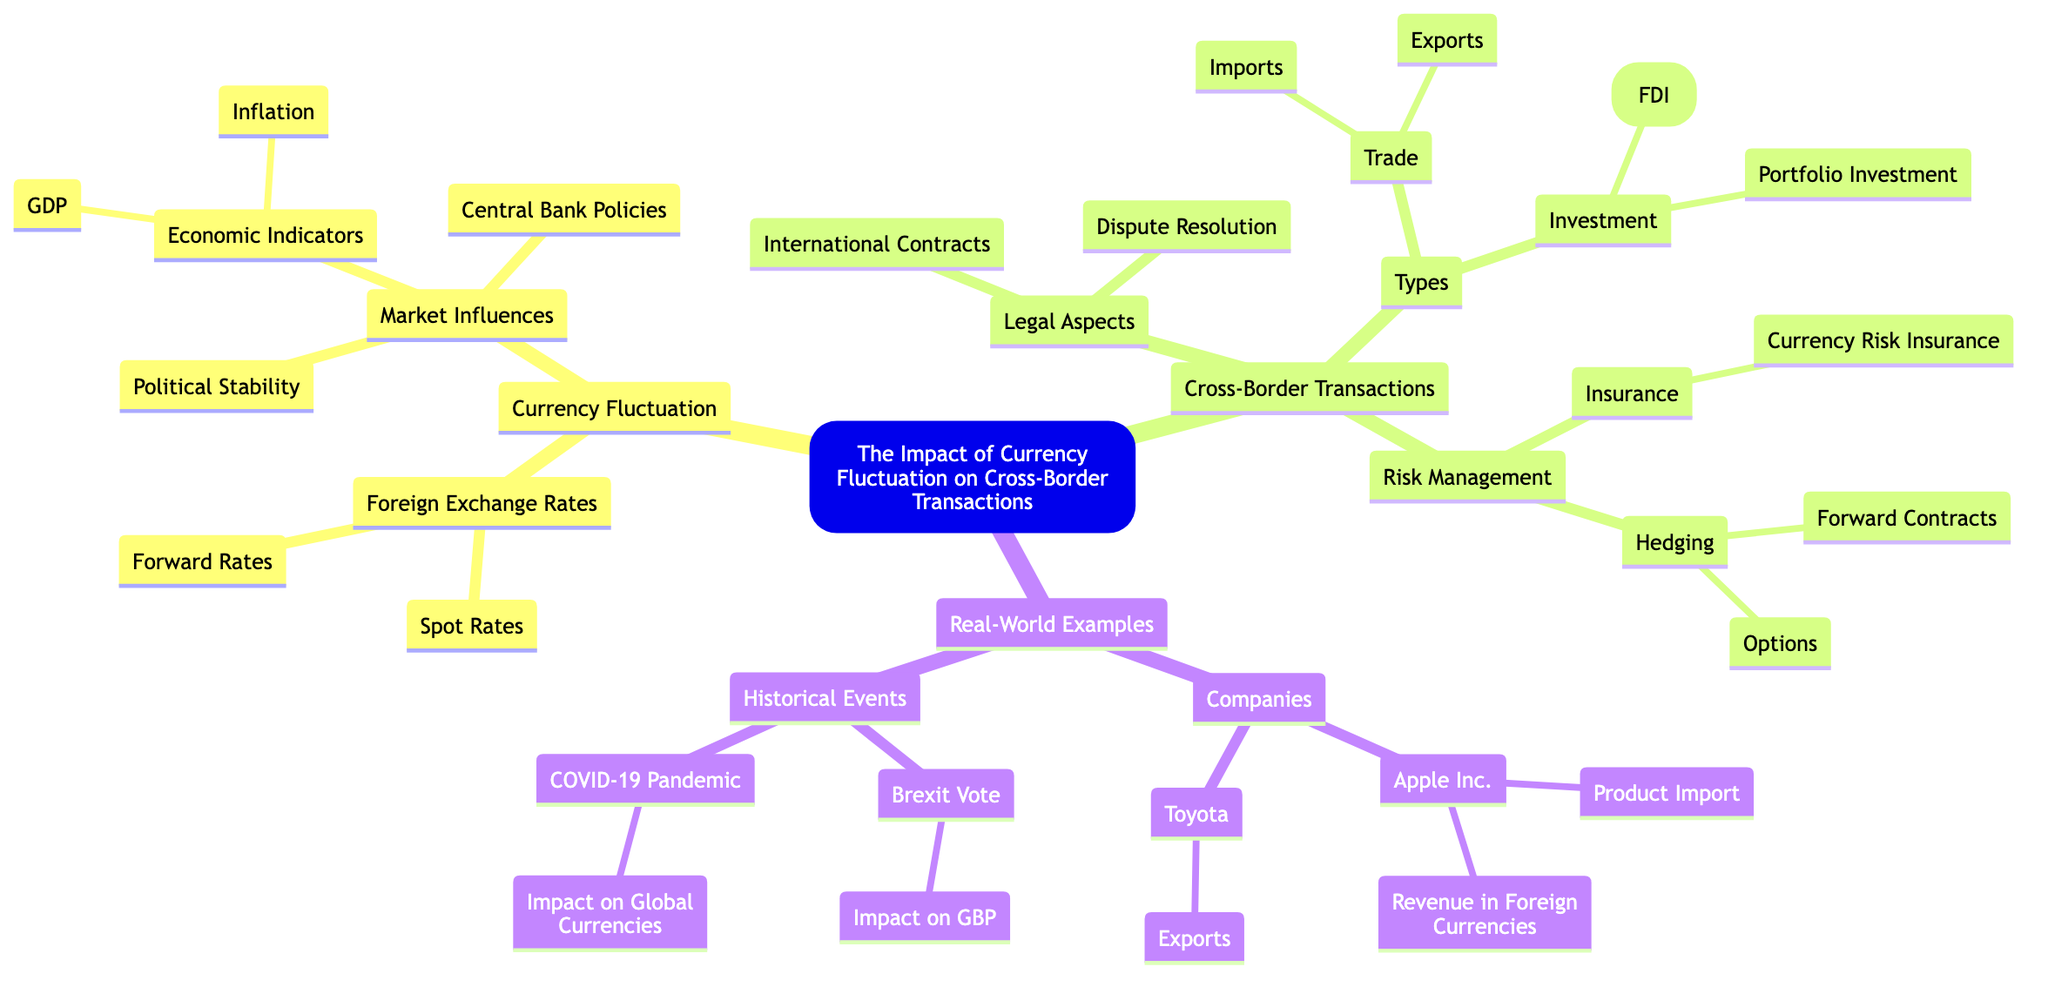What are the two main components of Currency Fluctuation? The diagram shows that Currency Fluctuation consists of two main components: Foreign Exchange Rates and Market Influences.
Answer: Foreign Exchange Rates, Market Influences How many types of Cross-Border Transactions are listed in the diagram? The diagram indicates that there are three main categories under Cross-Border Transactions: Types, Legal Aspects, and Risk Management. Therefore, the total is three.
Answer: 3 What are the two components of Foreign Exchange Rates? The diagram displays two components under Foreign Exchange Rates: Spot Rates and Forward Rates.
Answer: Spot Rates, Forward Rates Which company is associated with Product Import in Real-World Examples? The diagram highlights that Apple Inc. is specifically connected to the component of Product Import under Companies.
Answer: Apple Inc What are the two forms of Investment in Cross-Border Transactions? According to the diagram, the two forms of Investment listed are Foreign Direct Investment (FDI) and Portfolio Investment, as shown under the Investment category.
Answer: Foreign Direct Investment (FDI), Portfolio Investment How does Political Stability influence Currency Fluctuation? The diagram indicates that Political Stability is a component of Market Influences, which means it affects Foreign Exchange Rates and, consequently, Currency Fluctuation. The reasoning is that fluctuations in currency value may be driven by the political climate of a country.
Answer: Through Market Influences What is the relationship between Hedging and its associated strategies? The diagram illustrates that Hedging is a broader category that includes specific strategies: Forward Contracts and Options, which are methods to manage risk related to currency fluctuations in Cross-Border Transactions.
Answer: Hedging includes Forward Contracts and Options Which historical event is linked to the Impact on GBP? The diagram specifies that the Brexit Vote is linked to the Impact on GBP, indicating that this event has had notable effects on the value of the British pound.
Answer: Brexit Vote What insurance is mentioned in the context of Risk Management for Currency Fluctuation? The diagram shows that Currency Risk Insurance is the specific type of insurance mentioned under Risk Management, designed to mitigate risks associated with currency fluctuations.
Answer: Currency Risk Insurance 